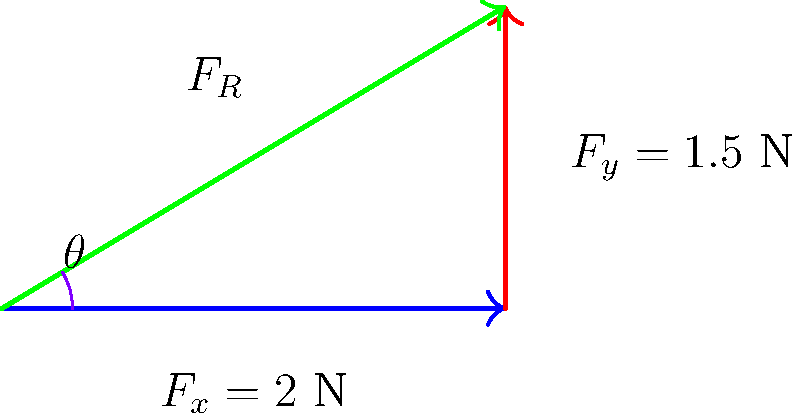During a minimally invasive heart surgery, a surgeon applies two perpendicular forces to a surgical tool: a horizontal force of 2 N and a vertical force of 1.5 N. What is the magnitude of the resultant force applied to the tool, and at what angle from the horizontal is this force directed? To solve this problem, we'll use vector addition and the Pythagorean theorem:

1. Identify the given forces:
   $F_x = 2$ N (horizontal)
   $F_y = 1.5$ N (vertical)

2. Calculate the magnitude of the resultant force using the Pythagorean theorem:
   $F_R = \sqrt{F_x^2 + F_y^2}$
   $F_R = \sqrt{2^2 + 1.5^2}$
   $F_R = \sqrt{4 + 2.25}$
   $F_R = \sqrt{6.25}$
   $F_R = 2.5$ N

3. Calculate the angle of the resultant force from the horizontal using trigonometry:
   $\theta = \tan^{-1}(\frac{F_y}{F_x})$
   $\theta = \tan^{-1}(\frac{1.5}{2})$
   $\theta = \tan^{-1}(0.75)$
   $\theta \approx 36.87°$

Therefore, the magnitude of the resultant force is 2.5 N, and it is directed at an angle of approximately 36.87° from the horizontal.
Answer: 2.5 N, 36.87° 